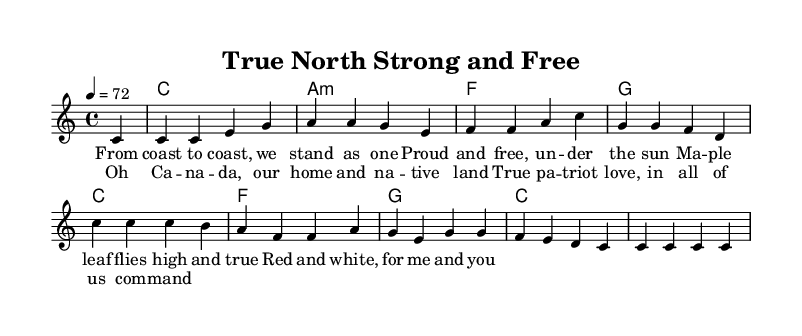What is the key signature of this music? The key signature is C major, which has no sharps or flats.
Answer: C major What is the time signature of the piece? The time signature shown in the music is 4/4, indicating there are four beats in each measure.
Answer: 4/4 What is the tempo marking for this piece? The tempo marking indicates a speed of 72 beats per minute, which dictates how fast the piece should be played.
Answer: 72 How many measures are in the verse? The verse consists of four distinct lines, each containing one measure, resulting in a total of four measures.
Answer: Four What is the syllable count of the first line of the chorus? The first line of the chorus "Oh Canada, our home and native land" contains a total of eight syllables, which can be counted for rhythmic and melodic purposes.
Answer: Eight What chords are used in the harmonies section? The chords indicated in the harmonies section are C major, A minor, F major, and G major, which are common in many songs.
Answer: C, A minor, F, G What musical style does this piece represent? This piece represents reggae, characterized by its offbeat rhythms and themes of cultural pride, which is evident in the lyrics and overall structure.
Answer: Reggae 